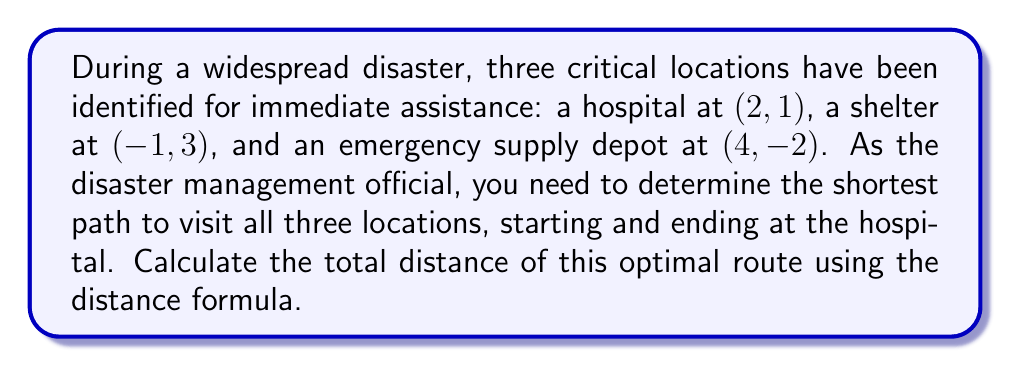Show me your answer to this math problem. To solve this problem, we'll follow these steps:

1) First, let's calculate the distances between each pair of points using the distance formula:
   $d = \sqrt{(x_2-x_1)^2 + (y_2-y_1)^2}$

   Hospital (H) to Shelter (S):
   $d_{HS} = \sqrt{((-1)-2)^2 + (3-1)^2} = \sqrt{(-3)^2 + 2^2} = \sqrt{13}$

   Hospital (H) to Depot (D):
   $d_{HD} = \sqrt{(4-2)^2 + (-2-1)^2} = \sqrt{2^2 + (-3)^2} = \sqrt{13}$

   Shelter (S) to Depot (D):
   $d_{SD} = \sqrt{(4-(-1))^2 + (-2-3)^2} = \sqrt{5^2 + (-5)^2} = \sqrt{50} = 5\sqrt{2}$

2) Now, we need to determine the shortest path that starts at the hospital, visits both other locations, and returns to the hospital. There are two possible routes:

   Route 1: Hospital -> Shelter -> Depot -> Hospital
   Distance = $d_{HS} + d_{SD} + d_{HD} = \sqrt{13} + 5\sqrt{2} + \sqrt{13}$

   Route 2: Hospital -> Depot -> Shelter -> Hospital
   Distance = $d_{HD} + d_{SD} + d_{HS} = \sqrt{13} + 5\sqrt{2} + \sqrt{13}$

3) We can see that both routes have the same total distance. This is because the problem forms an isosceles triangle, with the hospital-shelter and hospital-depot distances being equal.

4) Therefore, the shortest path is either of these routes, with a total distance of:

   $2\sqrt{13} + 5\sqrt{2}$

This can be left in this form or approximated to a decimal if needed.
Answer: The shortest path to visit all locations, starting and ending at the hospital, has a total distance of $2\sqrt{13} + 5\sqrt{2}$ units (approximately 11.18 units). 